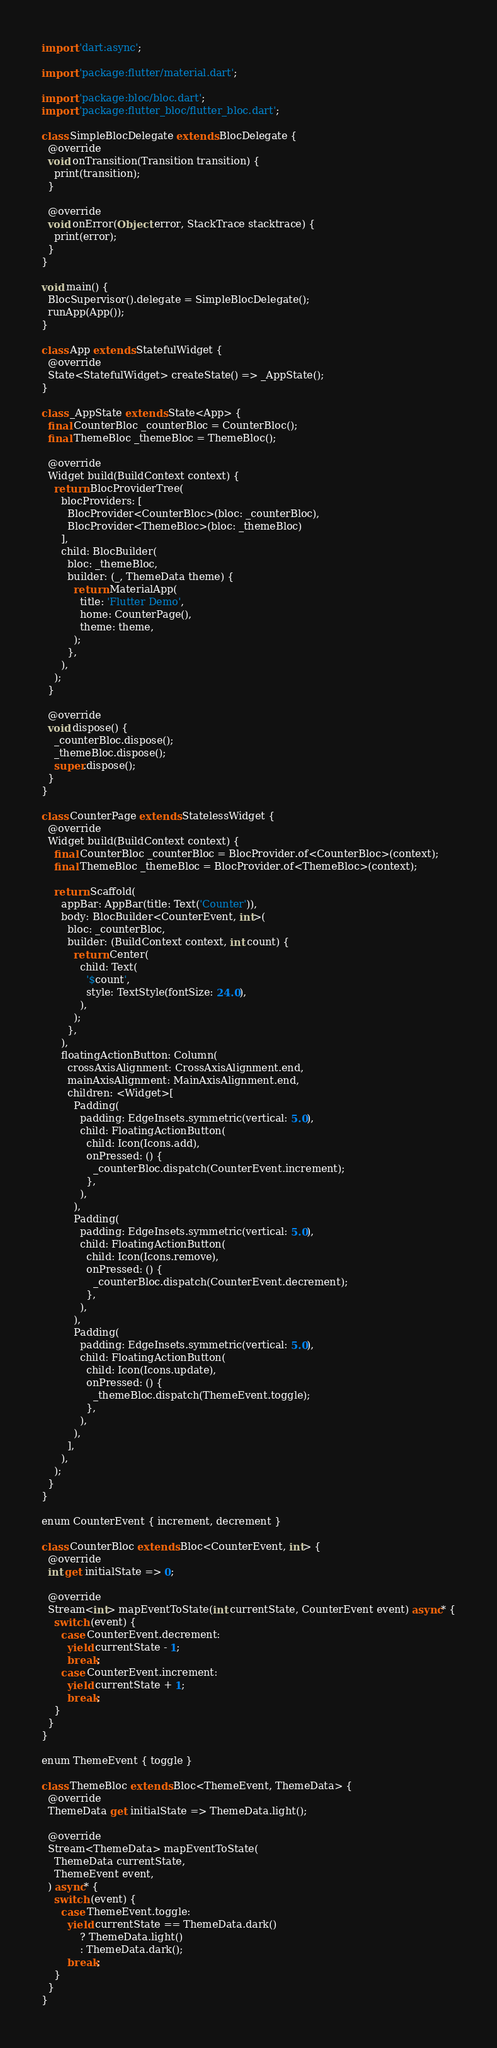Convert code to text. <code><loc_0><loc_0><loc_500><loc_500><_Dart_>import 'dart:async';

import 'package:flutter/material.dart';

import 'package:bloc/bloc.dart';
import 'package:flutter_bloc/flutter_bloc.dart';

class SimpleBlocDelegate extends BlocDelegate {
  @override
  void onTransition(Transition transition) {
    print(transition);
  }

  @override
  void onError(Object error, StackTrace stacktrace) {
    print(error);
  }
}

void main() {
  BlocSupervisor().delegate = SimpleBlocDelegate();
  runApp(App());
}

class App extends StatefulWidget {
  @override
  State<StatefulWidget> createState() => _AppState();
}

class _AppState extends State<App> {
  final CounterBloc _counterBloc = CounterBloc();
  final ThemeBloc _themeBloc = ThemeBloc();

  @override
  Widget build(BuildContext context) {
    return BlocProviderTree(
      blocProviders: [
        BlocProvider<CounterBloc>(bloc: _counterBloc),
        BlocProvider<ThemeBloc>(bloc: _themeBloc)
      ],
      child: BlocBuilder(
        bloc: _themeBloc,
        builder: (_, ThemeData theme) {
          return MaterialApp(
            title: 'Flutter Demo',
            home: CounterPage(),
            theme: theme,
          );
        },
      ),
    );
  }

  @override
  void dispose() {
    _counterBloc.dispose();
    _themeBloc.dispose();
    super.dispose();
  }
}

class CounterPage extends StatelessWidget {
  @override
  Widget build(BuildContext context) {
    final CounterBloc _counterBloc = BlocProvider.of<CounterBloc>(context);
    final ThemeBloc _themeBloc = BlocProvider.of<ThemeBloc>(context);

    return Scaffold(
      appBar: AppBar(title: Text('Counter')),
      body: BlocBuilder<CounterEvent, int>(
        bloc: _counterBloc,
        builder: (BuildContext context, int count) {
          return Center(
            child: Text(
              '$count',
              style: TextStyle(fontSize: 24.0),
            ),
          );
        },
      ),
      floatingActionButton: Column(
        crossAxisAlignment: CrossAxisAlignment.end,
        mainAxisAlignment: MainAxisAlignment.end,
        children: <Widget>[
          Padding(
            padding: EdgeInsets.symmetric(vertical: 5.0),
            child: FloatingActionButton(
              child: Icon(Icons.add),
              onPressed: () {
                _counterBloc.dispatch(CounterEvent.increment);
              },
            ),
          ),
          Padding(
            padding: EdgeInsets.symmetric(vertical: 5.0),
            child: FloatingActionButton(
              child: Icon(Icons.remove),
              onPressed: () {
                _counterBloc.dispatch(CounterEvent.decrement);
              },
            ),
          ),
          Padding(
            padding: EdgeInsets.symmetric(vertical: 5.0),
            child: FloatingActionButton(
              child: Icon(Icons.update),
              onPressed: () {
                _themeBloc.dispatch(ThemeEvent.toggle);
              },
            ),
          ),
        ],
      ),
    );
  }
}

enum CounterEvent { increment, decrement }

class CounterBloc extends Bloc<CounterEvent, int> {
  @override
  int get initialState => 0;

  @override
  Stream<int> mapEventToState(int currentState, CounterEvent event) async* {
    switch (event) {
      case CounterEvent.decrement:
        yield currentState - 1;
        break;
      case CounterEvent.increment:
        yield currentState + 1;
        break;
    }
  }
}

enum ThemeEvent { toggle }

class ThemeBloc extends Bloc<ThemeEvent, ThemeData> {
  @override
  ThemeData get initialState => ThemeData.light();

  @override
  Stream<ThemeData> mapEventToState(
    ThemeData currentState,
    ThemeEvent event,
  ) async* {
    switch (event) {
      case ThemeEvent.toggle:
        yield currentState == ThemeData.dark()
            ? ThemeData.light()
            : ThemeData.dark();
        break;
    }
  }
}
</code> 